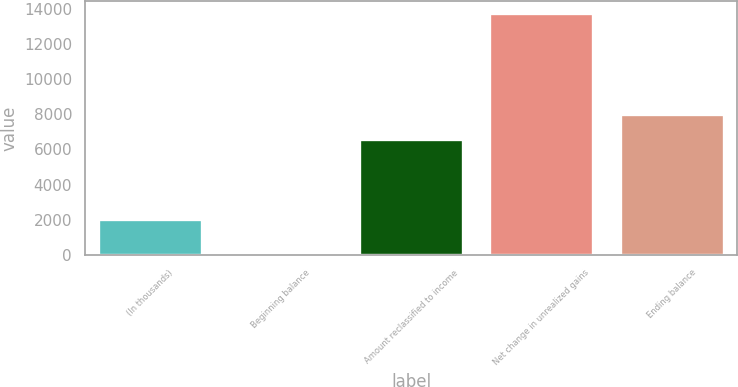Convert chart to OTSL. <chart><loc_0><loc_0><loc_500><loc_500><bar_chart><fcel>(In thousands)<fcel>Beginning balance<fcel>Amount reclassified to income<fcel>Net change in unrealized gains<fcel>Ending balance<nl><fcel>2015<fcel>20<fcel>6615<fcel>13745<fcel>7987.5<nl></chart> 